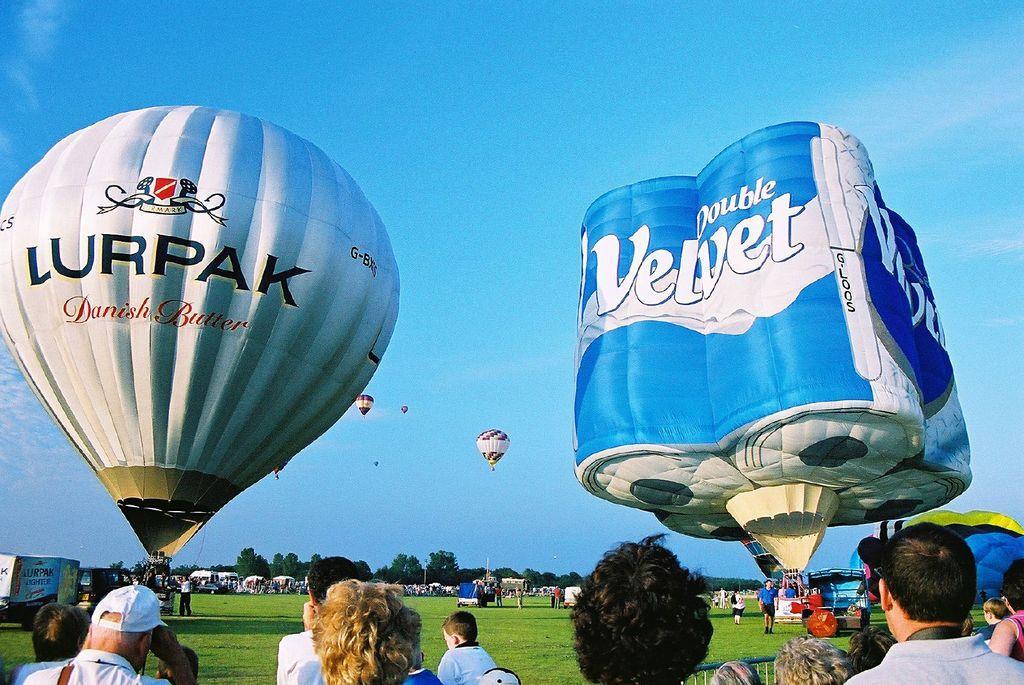Describe this image in one or two sentences. In this image, I can see hot air balloons, grass and there are groups of people. On the left side of the image, I can see vehicles. In the background there are trees and the sky and those are looking like stalls. 